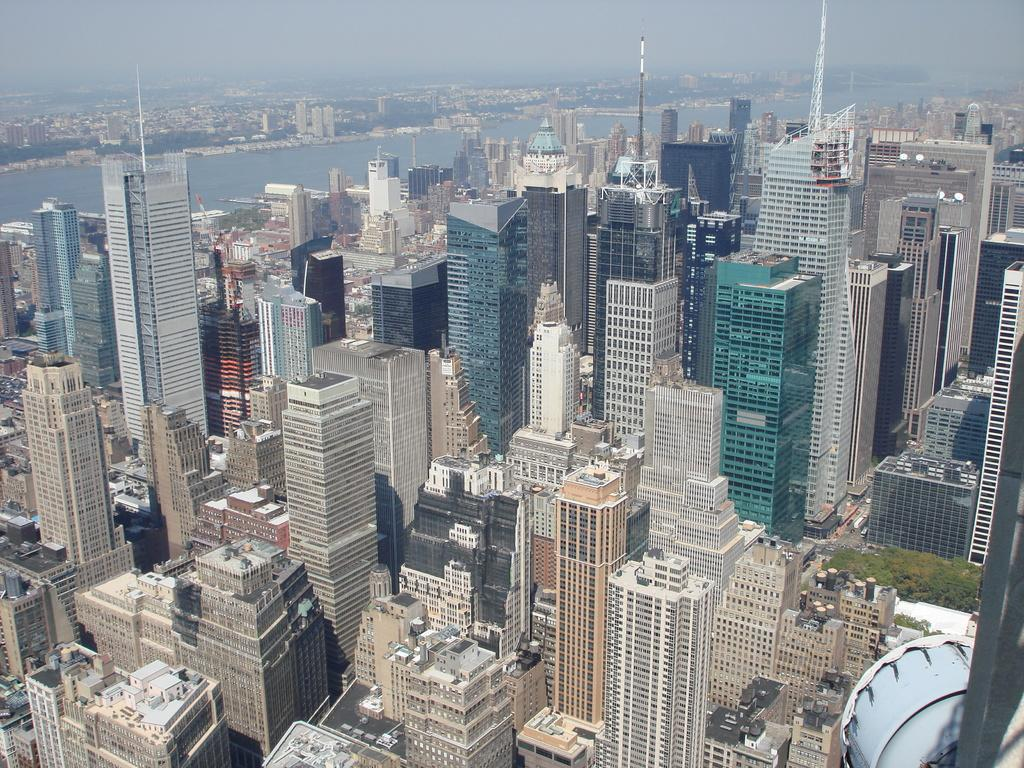What type of structures can be seen in the image? There are buildings in the image. What natural elements are present in the image? There are trees and water visible in the image. What are the poles used for in the image? The purpose of the poles in the image is not specified, but they could be for supporting wires or other infrastructure. What can be seen in the background of the image? The sky is visible in the background of the image. How many frogs are sitting on the buildings in the image? There are no frogs present in the image; it features buildings, trees, water, and poles. What type of insect can be seen flying around the trees in the image? There is no insect visible in the image; it only features trees, water, and poles. 